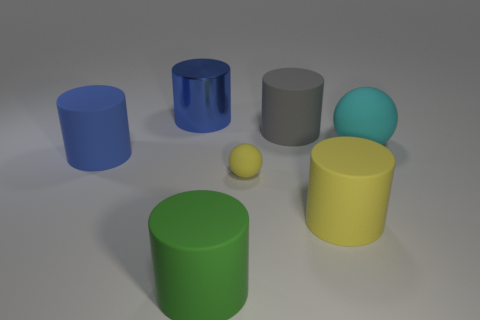Subtract all green cylinders. How many cylinders are left? 4 Subtract 1 cylinders. How many cylinders are left? 4 Subtract all green cylinders. How many cylinders are left? 4 Subtract all yellow cylinders. Subtract all purple balls. How many cylinders are left? 4 Add 2 small yellow spheres. How many objects exist? 9 Subtract all cylinders. How many objects are left? 2 Subtract all cyan things. Subtract all large metal blocks. How many objects are left? 6 Add 5 big gray things. How many big gray things are left? 6 Add 7 gray rubber things. How many gray rubber things exist? 8 Subtract 0 blue blocks. How many objects are left? 7 